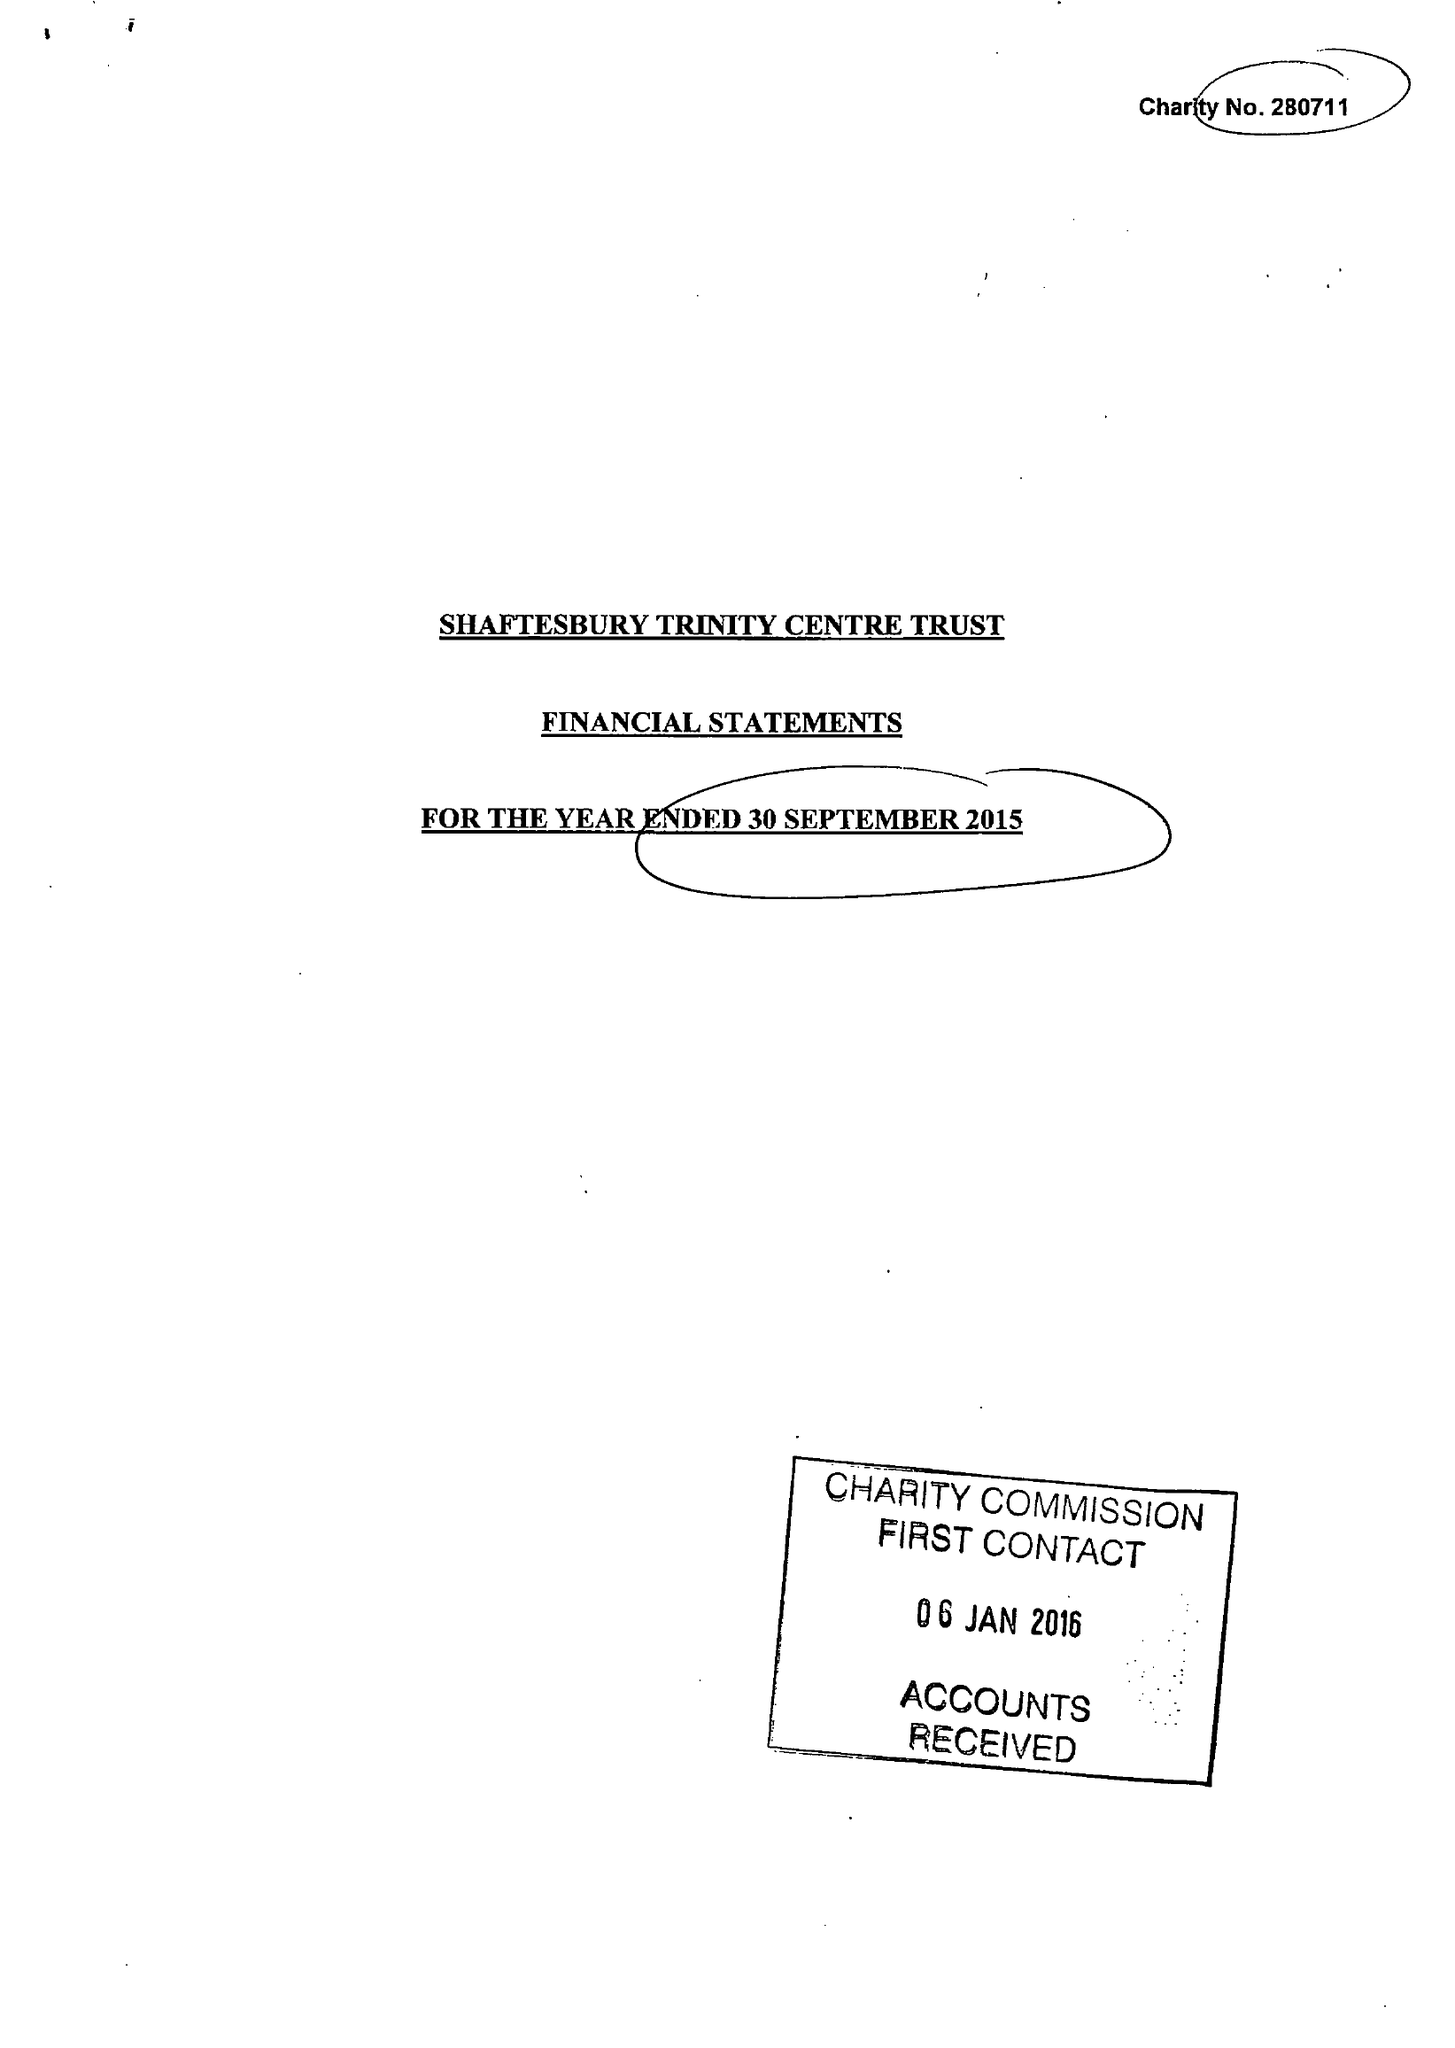What is the value for the income_annually_in_british_pounds?
Answer the question using a single word or phrase. 45213.00 